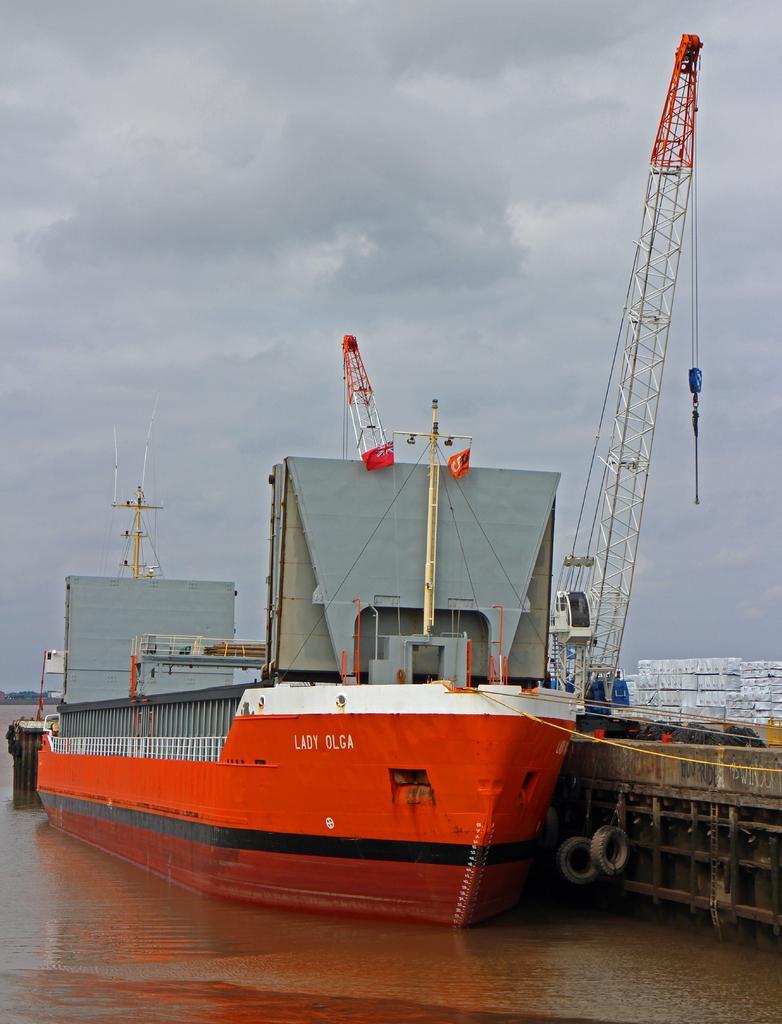Describe this image in one or two sentences. In this picture we can see boat above the water and we can see tyres, pole, crane and objects. In the background of the image we can see the sky with clouds. 